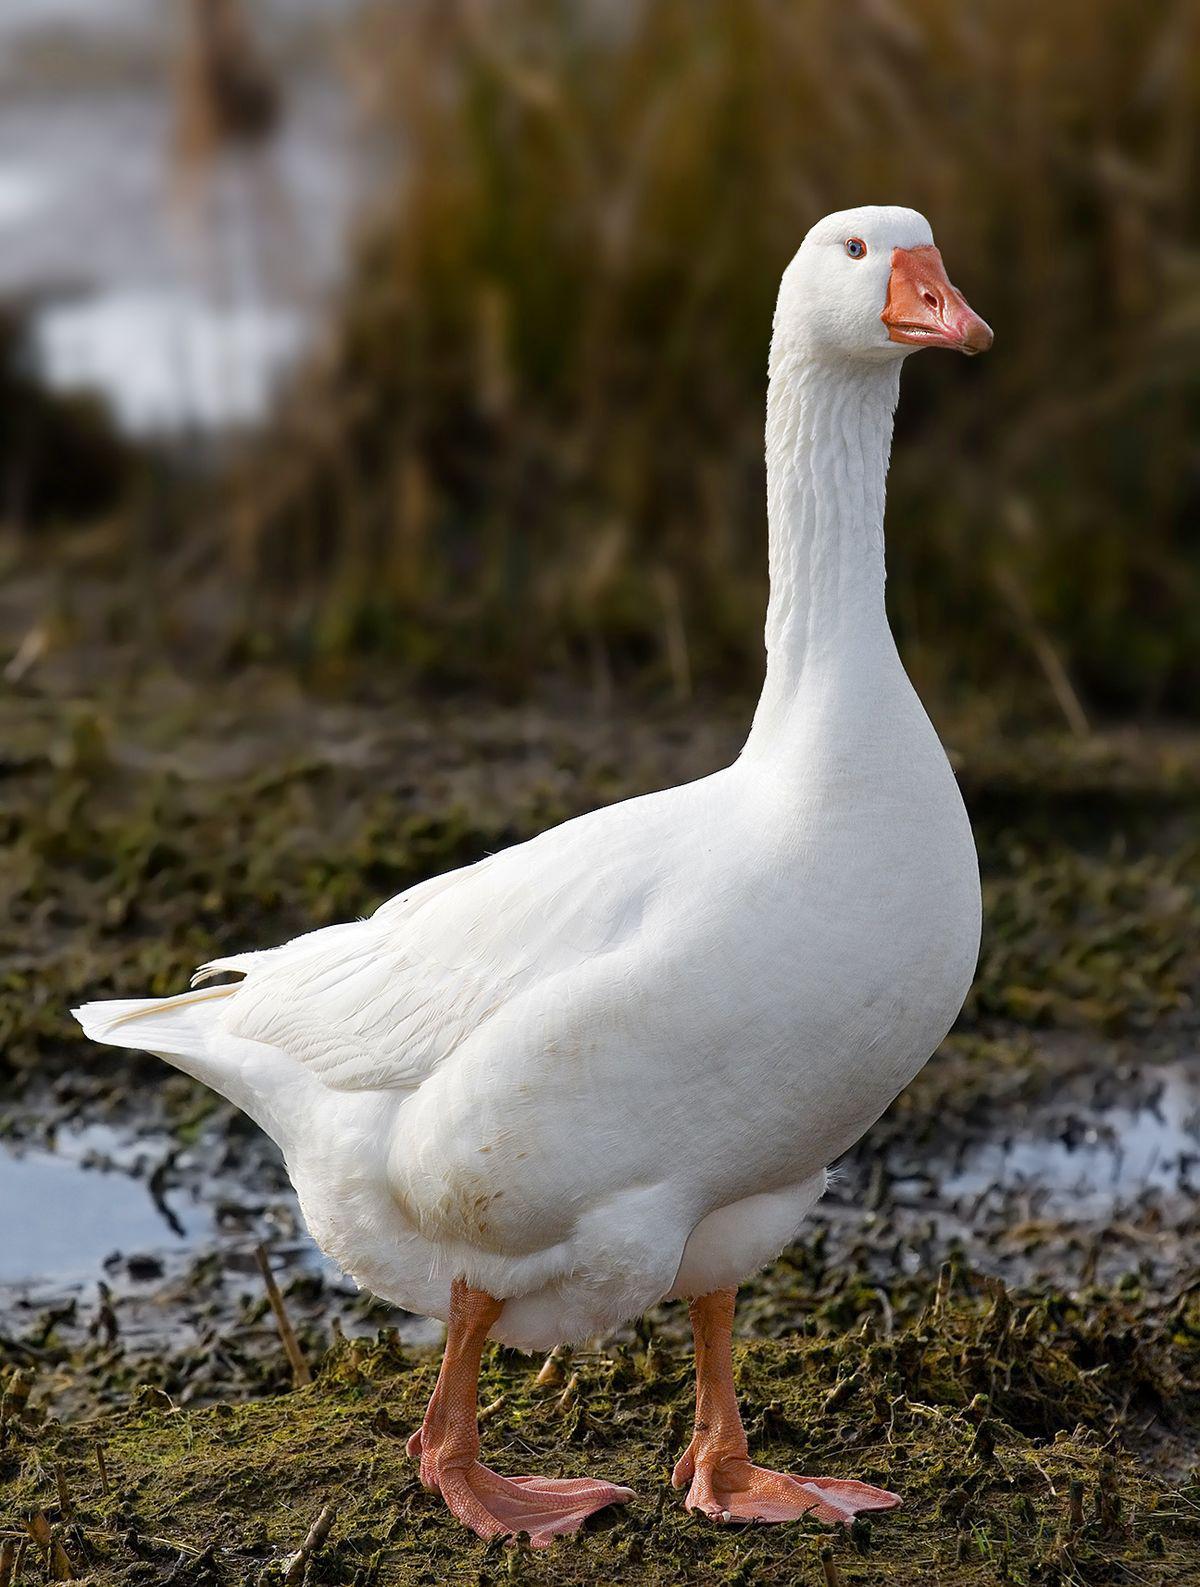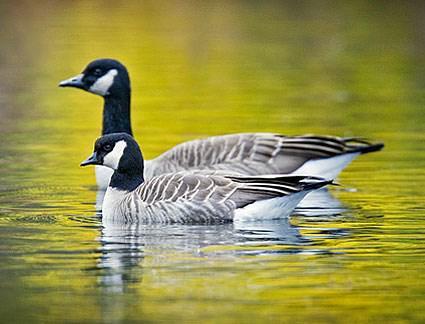The first image is the image on the left, the second image is the image on the right. For the images shown, is this caption "All images show birds that are flying." true? Answer yes or no. No. 